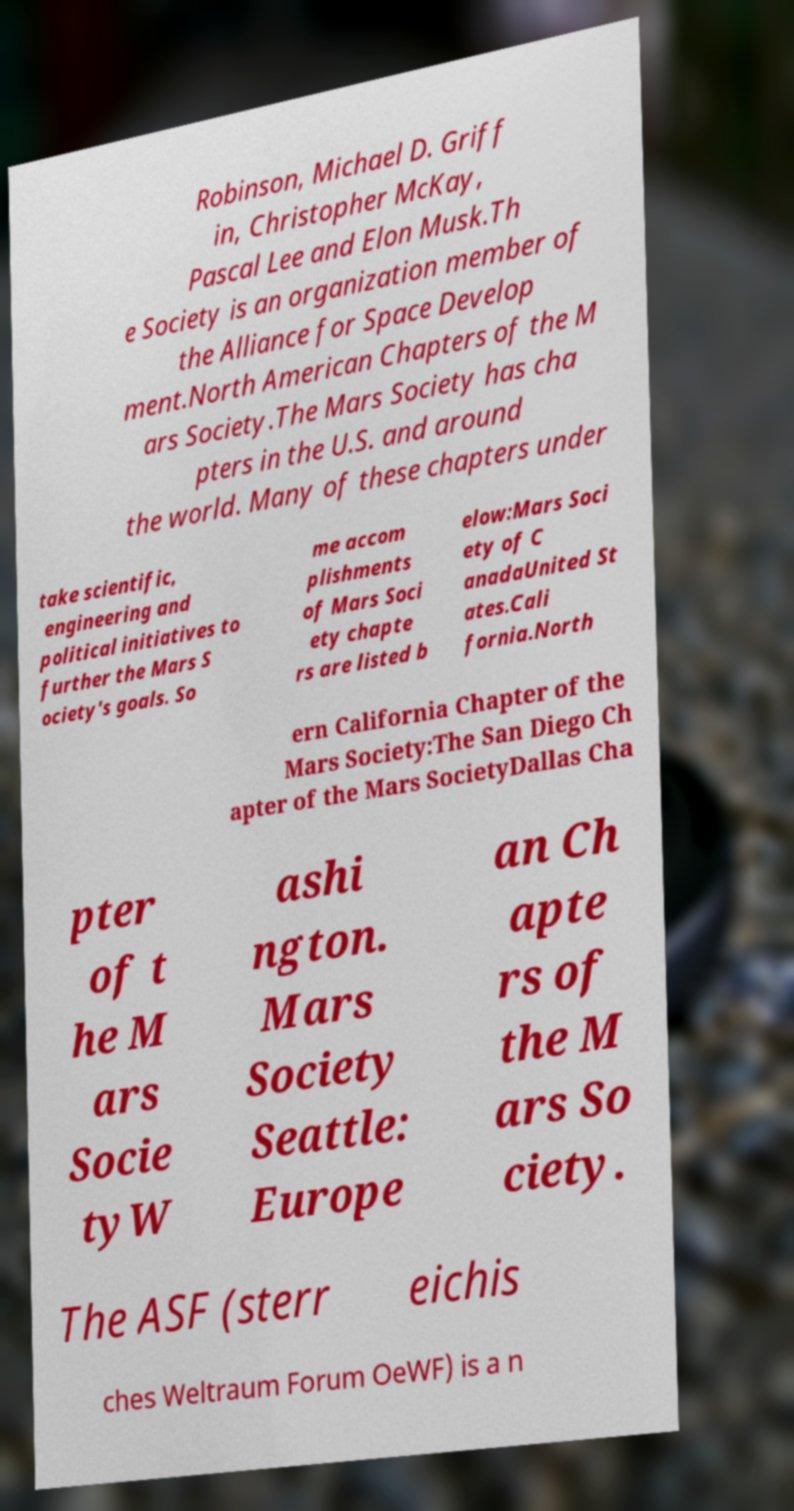Could you extract and type out the text from this image? Robinson, Michael D. Griff in, Christopher McKay, Pascal Lee and Elon Musk.Th e Society is an organization member of the Alliance for Space Develop ment.North American Chapters of the M ars Society.The Mars Society has cha pters in the U.S. and around the world. Many of these chapters under take scientific, engineering and political initiatives to further the Mars S ociety's goals. So me accom plishments of Mars Soci ety chapte rs are listed b elow:Mars Soci ety of C anadaUnited St ates.Cali fornia.North ern California Chapter of the Mars Society:The San Diego Ch apter of the Mars SocietyDallas Cha pter of t he M ars Socie tyW ashi ngton. Mars Society Seattle: Europe an Ch apte rs of the M ars So ciety. The ASF (sterr eichis ches Weltraum Forum OeWF) is a n 